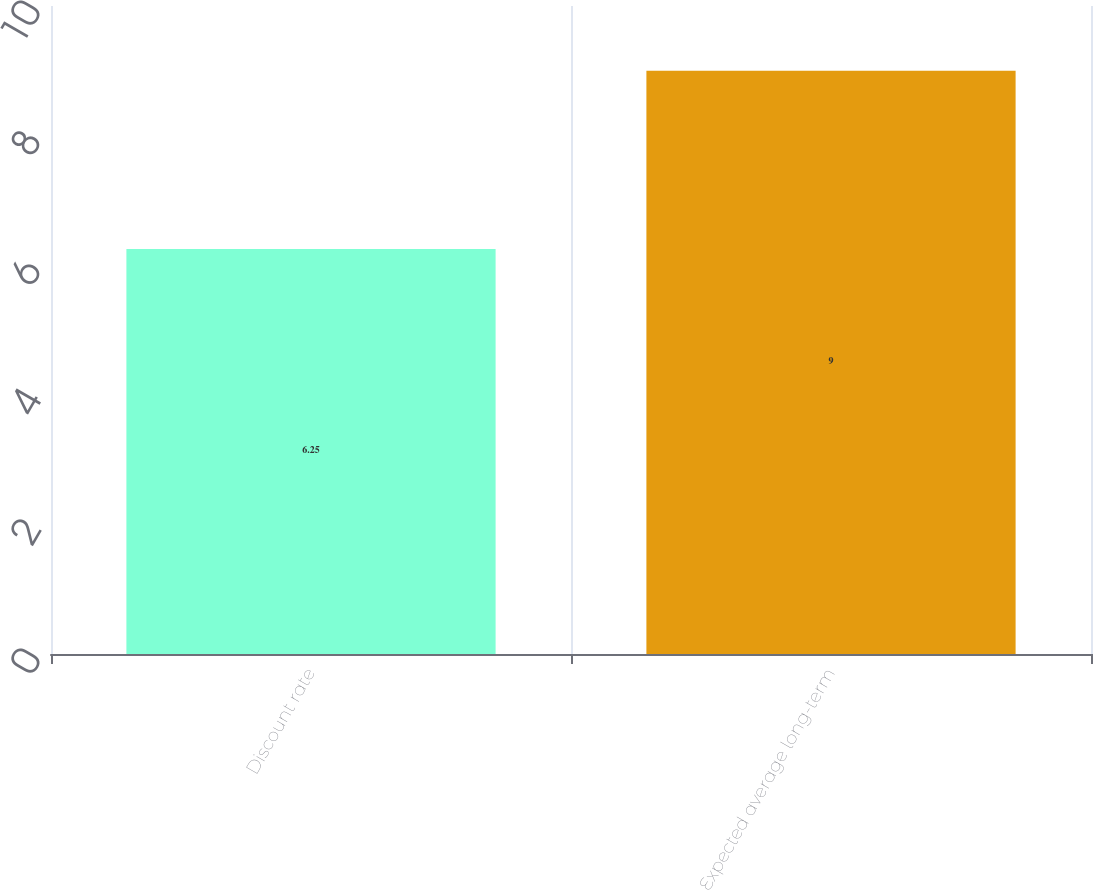<chart> <loc_0><loc_0><loc_500><loc_500><bar_chart><fcel>Discount rate<fcel>Expected average long-term<nl><fcel>6.25<fcel>9<nl></chart> 